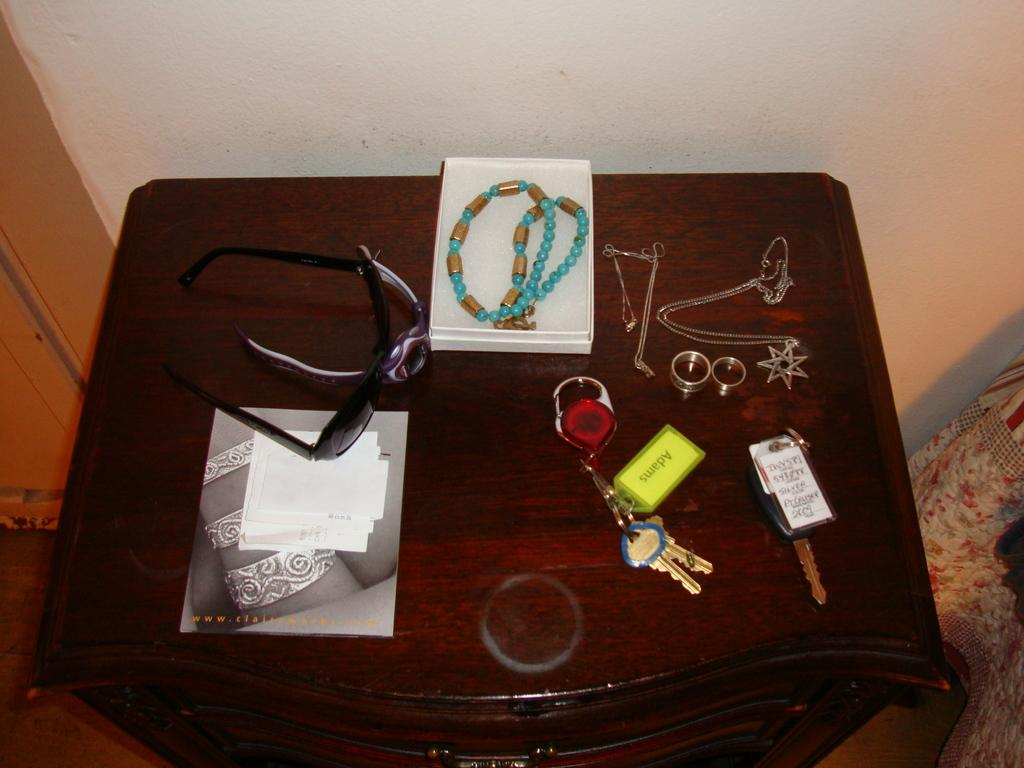What objects are on the table in the image? There are glasses, a watch, a chain, 2 rings, and keys on the table in the image. Can you describe the type of glasses on the table? The provided facts do not specify the type of glasses on the table. What is the purpose of the watch on the table? The purpose of the watch on the table is not specified in the provided facts. How many rings are on the table? There are 2 rings on the table. What else can be found on the table besides the rings? There are glasses, a watch, a chain, and keys on the table. What type of record can be seen on the table in the image? There is no record present on the table in the image. How does the sky affect the objects on the table in the image? The provided facts do not mention the sky or its effect on the objects on the table. 